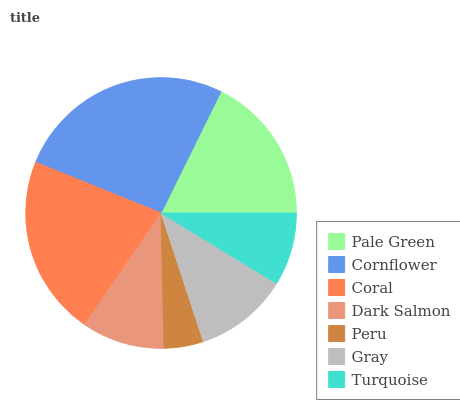Is Peru the minimum?
Answer yes or no. Yes. Is Cornflower the maximum?
Answer yes or no. Yes. Is Coral the minimum?
Answer yes or no. No. Is Coral the maximum?
Answer yes or no. No. Is Cornflower greater than Coral?
Answer yes or no. Yes. Is Coral less than Cornflower?
Answer yes or no. Yes. Is Coral greater than Cornflower?
Answer yes or no. No. Is Cornflower less than Coral?
Answer yes or no. No. Is Gray the high median?
Answer yes or no. Yes. Is Gray the low median?
Answer yes or no. Yes. Is Cornflower the high median?
Answer yes or no. No. Is Coral the low median?
Answer yes or no. No. 